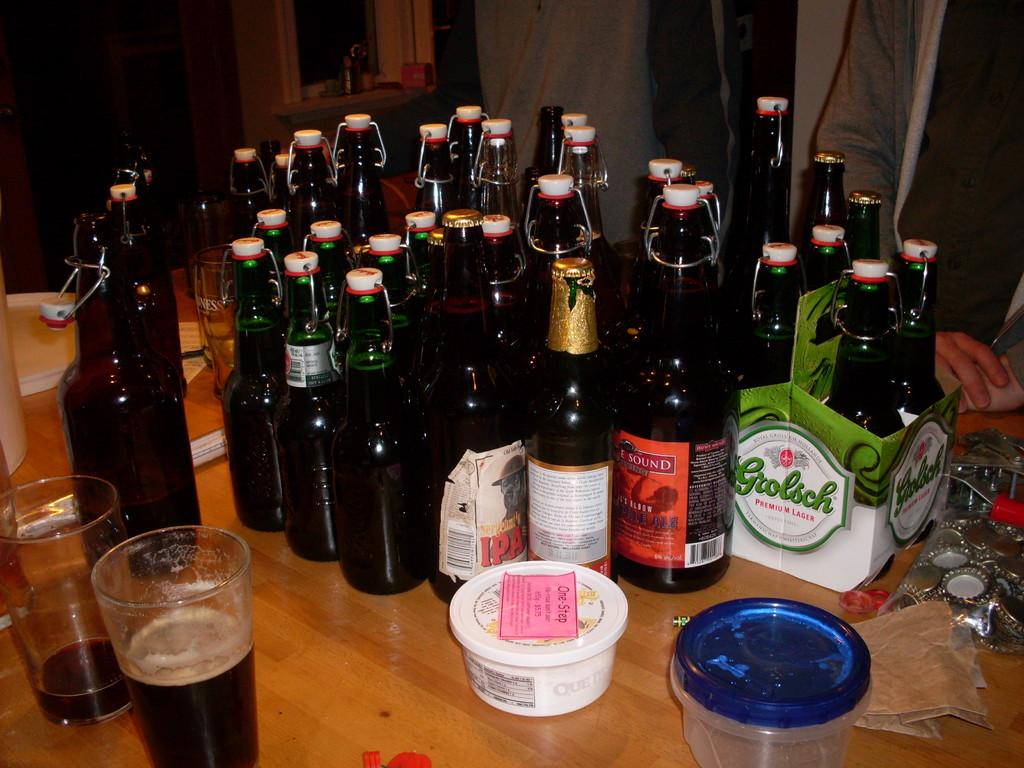What kind of beer is this?
Offer a very short reply. Grolsch. What is the written below the grolsch logo?
Offer a terse response. Premium lager. 